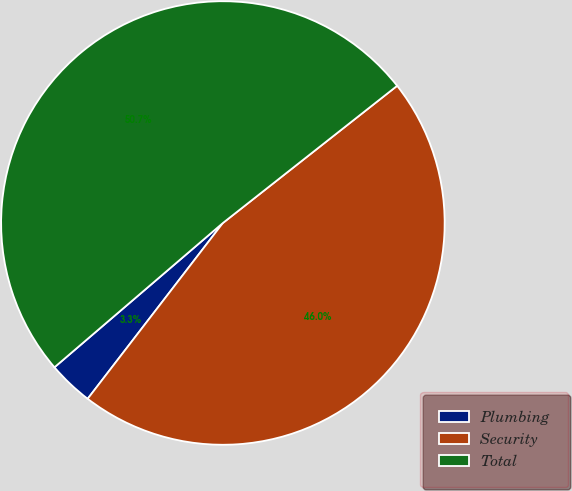Convert chart. <chart><loc_0><loc_0><loc_500><loc_500><pie_chart><fcel>Plumbing<fcel>Security<fcel>Total<nl><fcel>3.29%<fcel>46.05%<fcel>50.66%<nl></chart> 